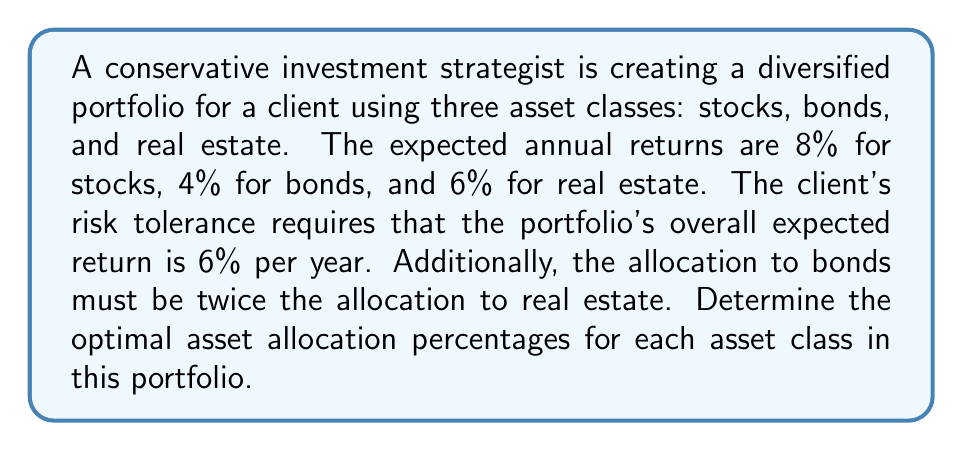Teach me how to tackle this problem. Let's approach this step-by-step:

1) Let $x$ = percentage allocated to stocks
   Let $y$ = percentage allocated to bonds
   Let $z$ = percentage allocated to real estate

2) We know that the total allocation must equal 100%:
   $$x + y + z = 100\%$$

3) We're told that the allocation to bonds must be twice the allocation to real estate:
   $$y = 2z$$

4) The expected return of the portfolio is 6%. We can express this as an equation:
   $$0.08x + 0.04y + 0.06z = 6$$

5) Substitute $y = 2z$ into the equations from steps 2 and 4:
   $$x + 2z + z = 100\%$$
   $$0.08x + 0.04(2z) + 0.06z = 6$$

6) Simplify:
   $$x + 3z = 100\%$$
   $$0.08x + 0.14z = 6$$

7) Multiply the first equation by 0.08:
   $$0.08x + 0.24z = 8$$

8) Subtract the equation in step 6 from this:
   $$0.10z = 2$$

9) Solve for $z$:
   $$z = 20\%$$

10) Substitute this back into $x + 3z = 100\%$:
    $$x + 3(20) = 100\%$$
    $$x = 40\%$$

11) Calculate $y$ using $y = 2z$:
    $$y = 2(20) = 40\%$$

Therefore, the optimal asset allocation is 40% stocks, 40% bonds, and 20% real estate.
Answer: 40% stocks, 40% bonds, 20% real estate 